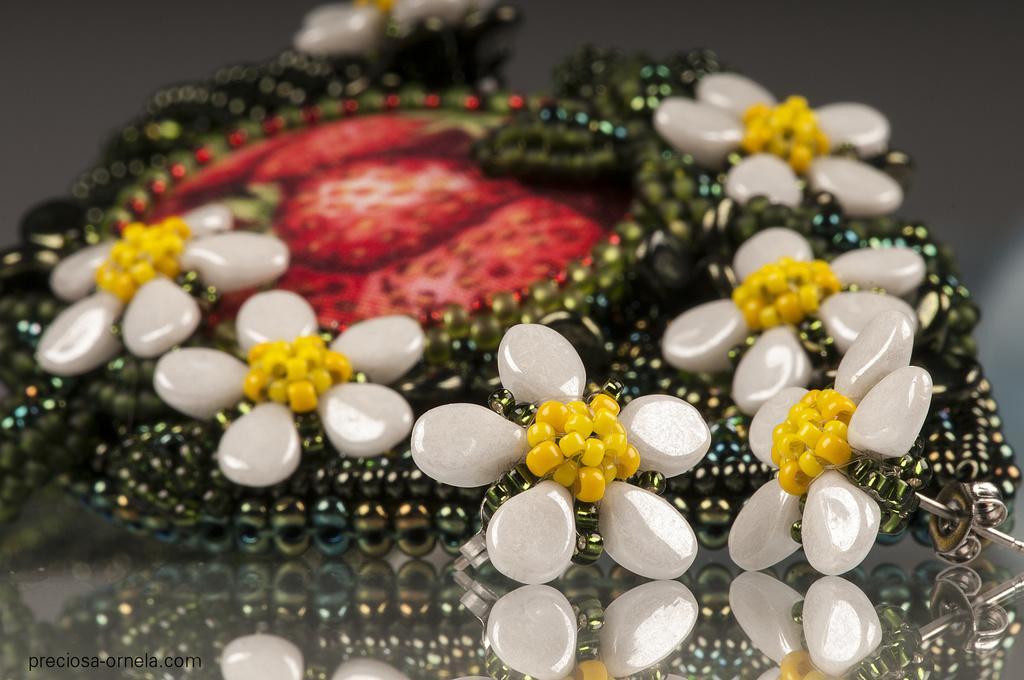What type of object is featured in the image? There is a jewelry item in the image. Can you see a pocket in the image? There is no mention of a pocket in the provided facts, and therefore it cannot be determined if one is present in the image. 